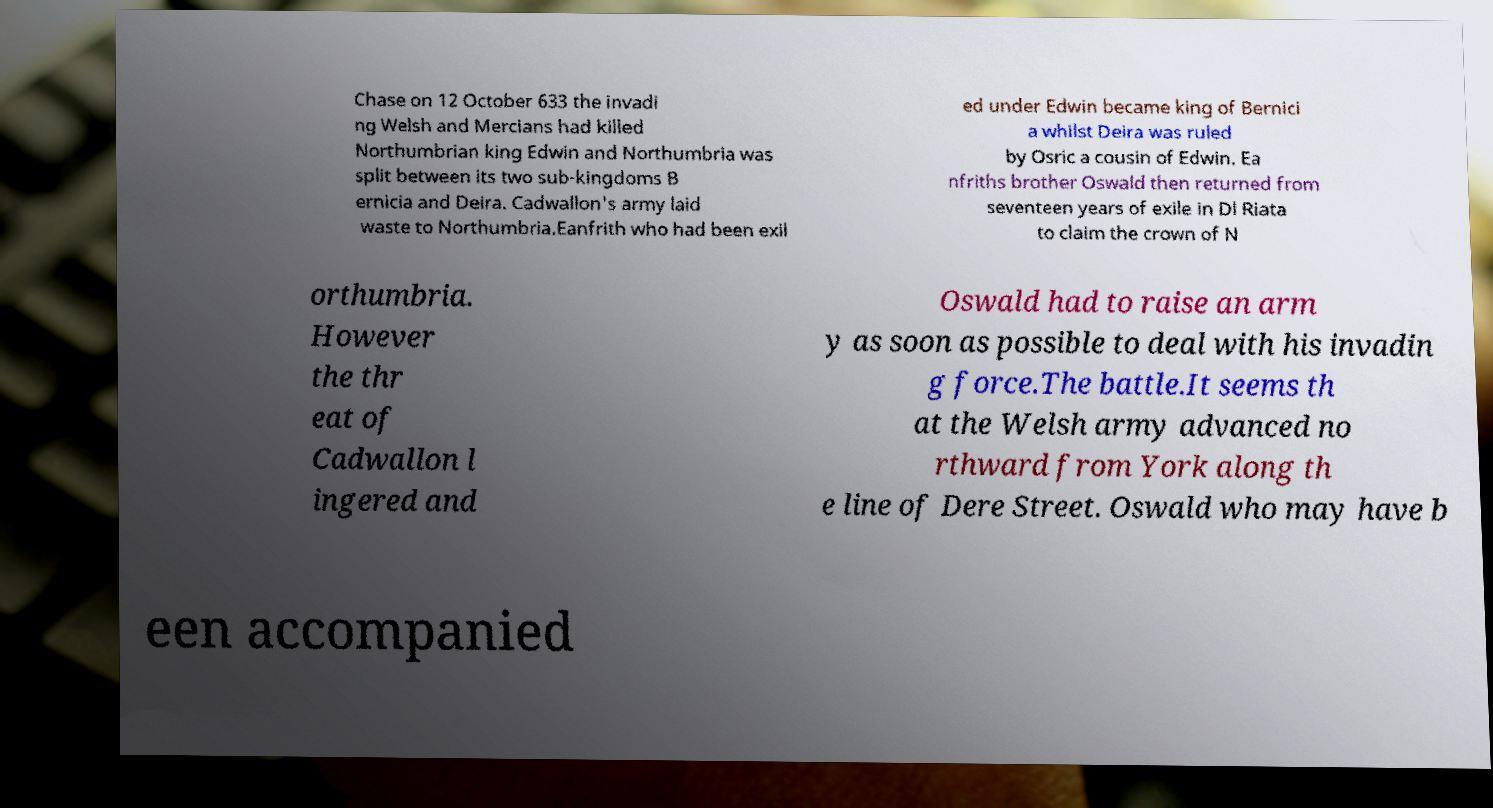What messages or text are displayed in this image? I need them in a readable, typed format. Chase on 12 October 633 the invadi ng Welsh and Mercians had killed Northumbrian king Edwin and Northumbria was split between its two sub-kingdoms B ernicia and Deira. Cadwallon's army laid waste to Northumbria.Eanfrith who had been exil ed under Edwin became king of Bernici a whilst Deira was ruled by Osric a cousin of Edwin. Ea nfriths brother Oswald then returned from seventeen years of exile in Dl Riata to claim the crown of N orthumbria. However the thr eat of Cadwallon l ingered and Oswald had to raise an arm y as soon as possible to deal with his invadin g force.The battle.It seems th at the Welsh army advanced no rthward from York along th e line of Dere Street. Oswald who may have b een accompanied 